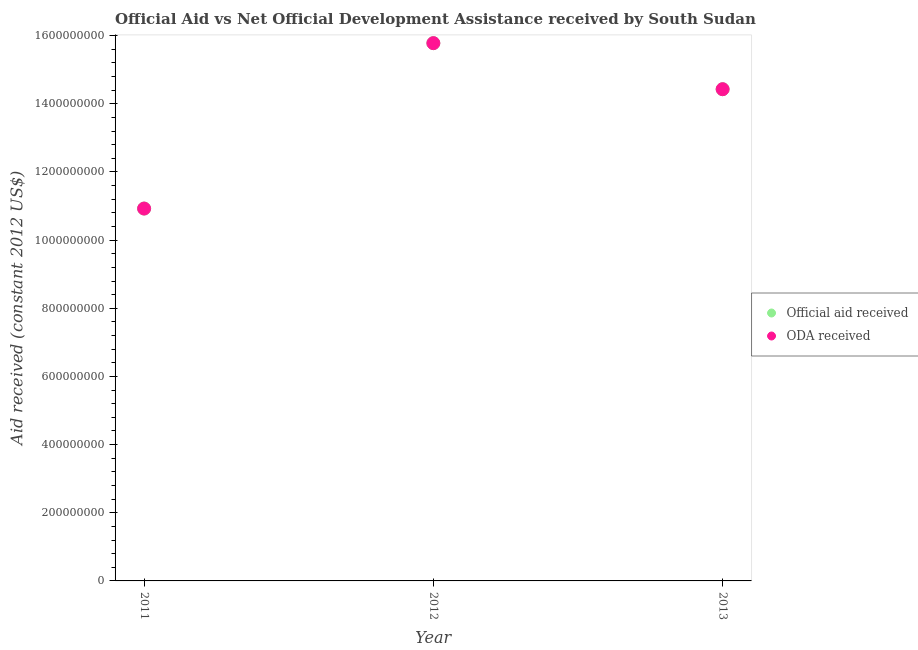Is the number of dotlines equal to the number of legend labels?
Make the answer very short. Yes. What is the oda received in 2011?
Keep it short and to the point. 1.09e+09. Across all years, what is the maximum oda received?
Ensure brevity in your answer.  1.58e+09. Across all years, what is the minimum official aid received?
Your answer should be very brief. 1.09e+09. What is the total oda received in the graph?
Keep it short and to the point. 4.11e+09. What is the difference between the official aid received in 2011 and that in 2013?
Your answer should be compact. -3.50e+08. What is the difference between the oda received in 2012 and the official aid received in 2013?
Your answer should be very brief. 1.35e+08. What is the average official aid received per year?
Your answer should be compact. 1.37e+09. In the year 2011, what is the difference between the official aid received and oda received?
Your answer should be very brief. 0. What is the ratio of the official aid received in 2012 to that in 2013?
Provide a succinct answer. 1.09. Is the oda received in 2011 less than that in 2013?
Make the answer very short. Yes. What is the difference between the highest and the second highest official aid received?
Your response must be concise. 1.35e+08. What is the difference between the highest and the lowest official aid received?
Provide a short and direct response. 4.85e+08. Does the official aid received monotonically increase over the years?
Provide a succinct answer. No. How many dotlines are there?
Your answer should be compact. 2. How many years are there in the graph?
Your response must be concise. 3. Are the values on the major ticks of Y-axis written in scientific E-notation?
Your answer should be very brief. No. Where does the legend appear in the graph?
Your response must be concise. Center right. How many legend labels are there?
Keep it short and to the point. 2. What is the title of the graph?
Give a very brief answer. Official Aid vs Net Official Development Assistance received by South Sudan . Does "External balance on goods" appear as one of the legend labels in the graph?
Your answer should be compact. No. What is the label or title of the X-axis?
Keep it short and to the point. Year. What is the label or title of the Y-axis?
Keep it short and to the point. Aid received (constant 2012 US$). What is the Aid received (constant 2012 US$) of Official aid received in 2011?
Keep it short and to the point. 1.09e+09. What is the Aid received (constant 2012 US$) in ODA received in 2011?
Provide a succinct answer. 1.09e+09. What is the Aid received (constant 2012 US$) in Official aid received in 2012?
Provide a short and direct response. 1.58e+09. What is the Aid received (constant 2012 US$) of ODA received in 2012?
Offer a terse response. 1.58e+09. What is the Aid received (constant 2012 US$) in Official aid received in 2013?
Give a very brief answer. 1.44e+09. What is the Aid received (constant 2012 US$) in ODA received in 2013?
Make the answer very short. 1.44e+09. Across all years, what is the maximum Aid received (constant 2012 US$) in Official aid received?
Keep it short and to the point. 1.58e+09. Across all years, what is the maximum Aid received (constant 2012 US$) of ODA received?
Keep it short and to the point. 1.58e+09. Across all years, what is the minimum Aid received (constant 2012 US$) in Official aid received?
Provide a short and direct response. 1.09e+09. Across all years, what is the minimum Aid received (constant 2012 US$) of ODA received?
Your response must be concise. 1.09e+09. What is the total Aid received (constant 2012 US$) of Official aid received in the graph?
Offer a very short reply. 4.11e+09. What is the total Aid received (constant 2012 US$) of ODA received in the graph?
Offer a terse response. 4.11e+09. What is the difference between the Aid received (constant 2012 US$) in Official aid received in 2011 and that in 2012?
Provide a succinct answer. -4.85e+08. What is the difference between the Aid received (constant 2012 US$) of ODA received in 2011 and that in 2012?
Make the answer very short. -4.85e+08. What is the difference between the Aid received (constant 2012 US$) in Official aid received in 2011 and that in 2013?
Give a very brief answer. -3.50e+08. What is the difference between the Aid received (constant 2012 US$) of ODA received in 2011 and that in 2013?
Your answer should be compact. -3.50e+08. What is the difference between the Aid received (constant 2012 US$) of Official aid received in 2012 and that in 2013?
Keep it short and to the point. 1.35e+08. What is the difference between the Aid received (constant 2012 US$) in ODA received in 2012 and that in 2013?
Offer a very short reply. 1.35e+08. What is the difference between the Aid received (constant 2012 US$) in Official aid received in 2011 and the Aid received (constant 2012 US$) in ODA received in 2012?
Provide a succinct answer. -4.85e+08. What is the difference between the Aid received (constant 2012 US$) in Official aid received in 2011 and the Aid received (constant 2012 US$) in ODA received in 2013?
Your answer should be very brief. -3.50e+08. What is the difference between the Aid received (constant 2012 US$) in Official aid received in 2012 and the Aid received (constant 2012 US$) in ODA received in 2013?
Make the answer very short. 1.35e+08. What is the average Aid received (constant 2012 US$) of Official aid received per year?
Make the answer very short. 1.37e+09. What is the average Aid received (constant 2012 US$) of ODA received per year?
Provide a short and direct response. 1.37e+09. In the year 2011, what is the difference between the Aid received (constant 2012 US$) in Official aid received and Aid received (constant 2012 US$) in ODA received?
Your answer should be compact. 0. What is the ratio of the Aid received (constant 2012 US$) in Official aid received in 2011 to that in 2012?
Your answer should be compact. 0.69. What is the ratio of the Aid received (constant 2012 US$) in ODA received in 2011 to that in 2012?
Your response must be concise. 0.69. What is the ratio of the Aid received (constant 2012 US$) in Official aid received in 2011 to that in 2013?
Provide a succinct answer. 0.76. What is the ratio of the Aid received (constant 2012 US$) of ODA received in 2011 to that in 2013?
Make the answer very short. 0.76. What is the ratio of the Aid received (constant 2012 US$) of Official aid received in 2012 to that in 2013?
Ensure brevity in your answer.  1.09. What is the ratio of the Aid received (constant 2012 US$) in ODA received in 2012 to that in 2013?
Provide a short and direct response. 1.09. What is the difference between the highest and the second highest Aid received (constant 2012 US$) of Official aid received?
Keep it short and to the point. 1.35e+08. What is the difference between the highest and the second highest Aid received (constant 2012 US$) in ODA received?
Keep it short and to the point. 1.35e+08. What is the difference between the highest and the lowest Aid received (constant 2012 US$) of Official aid received?
Provide a short and direct response. 4.85e+08. What is the difference between the highest and the lowest Aid received (constant 2012 US$) in ODA received?
Your response must be concise. 4.85e+08. 